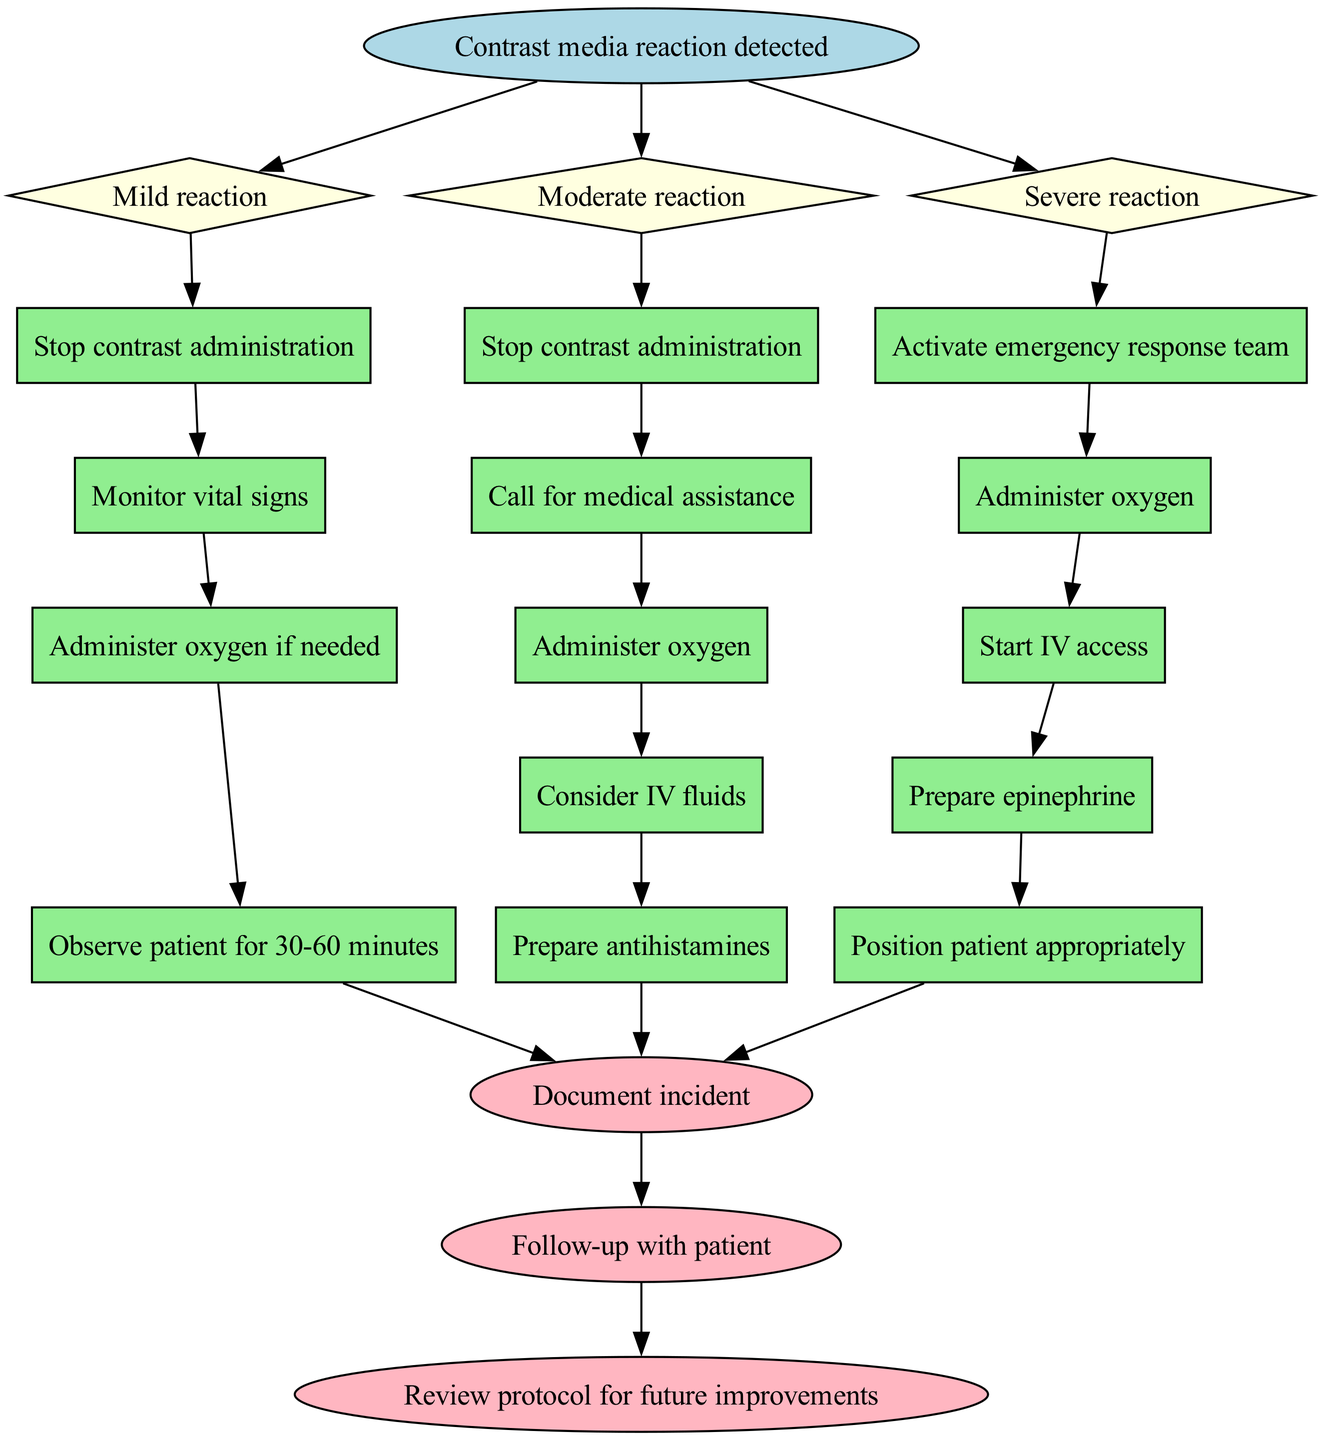What is the initial action when a contrast media reaction is detected? The flowchart starts with the node "Contrast media reaction detected," indicating that this is the trigger for the subsequent actions. Thus, the initial action is to stop contrast administration.
Answer: Stop contrast administration How many conditions are defined in the flowchart? The flowchart outlines three conditions: mild, moderate, and severe reactions. Each condition leads to different actions.
Answer: Three What action is taken during a moderate reaction after stopping contrast administration? Following the action of stopping contrast administration for a moderate reaction, the next action is to call for medical assistance. This is the second action listed under the moderate reaction.
Answer: Call for medical assistance What is the final step in the flowchart? The flowchart indicates that the last steps involve documenting the incident, following up with the patient, and reviewing the protocol for future improvements. All are considered part of the end actions.
Answer: Document incident Which action is common to both mild and moderate reactions? Both mild and moderate reactions include the action of administering oxygen. This is present in the actions listed for each of these conditions.
Answer: Administer oxygen What should be prepared for a severe reaction? In the case of a severe reaction, among the actions to be prepared is epinephrine. This specific action is critical for managing severe allergic reactions.
Answer: Prepare epinephrine How many total actions are there for a mild reaction? The flowchart specifies four actions under the mild reaction condition. These actions include stepping and monitoring vital signs.
Answer: Four After a mild reaction, for how long should the patient be observed? The flowchart instructs that the patient should be observed for 30-60 minutes after a mild reaction. This duration is meant for safety and monitoring.
Answer: 30-60 minutes What is the relationship between the condition nodes and action nodes? Each condition node is connected to its respective action nodes, showing that upon detecting a specific type of reaction, a series of prescribed actions must follow accordingly. Each condition flows into its set of actions.
Answer: Condition nodes lead to action nodes 